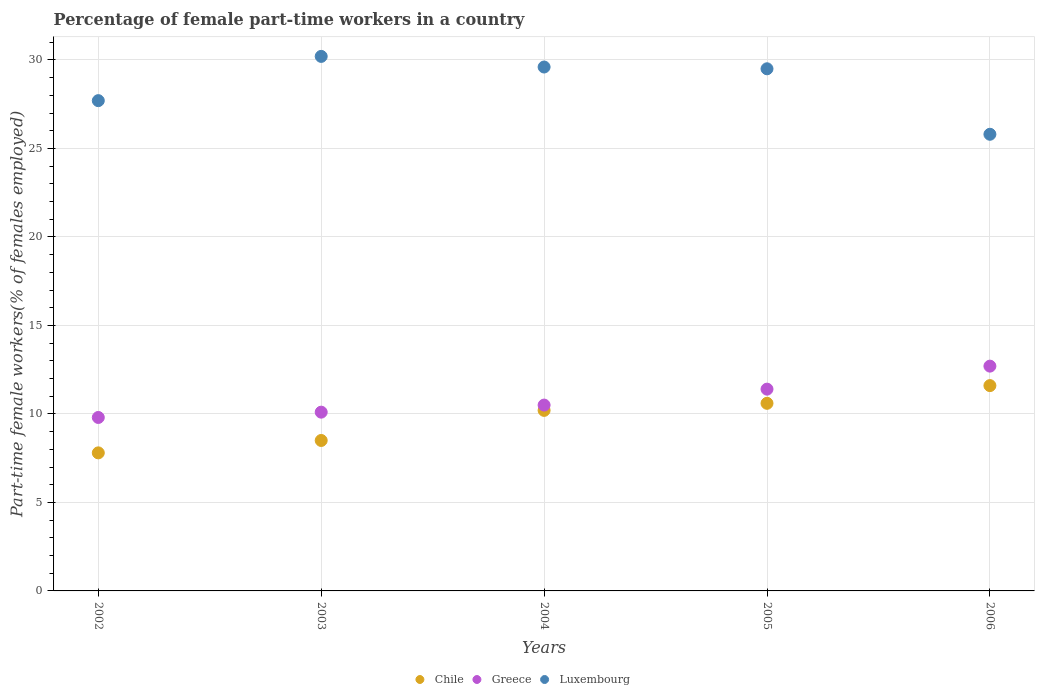What is the percentage of female part-time workers in Chile in 2004?
Keep it short and to the point. 10.2. Across all years, what is the maximum percentage of female part-time workers in Greece?
Provide a short and direct response. 12.7. Across all years, what is the minimum percentage of female part-time workers in Greece?
Provide a short and direct response. 9.8. In which year was the percentage of female part-time workers in Luxembourg minimum?
Give a very brief answer. 2006. What is the total percentage of female part-time workers in Chile in the graph?
Give a very brief answer. 48.7. What is the difference between the percentage of female part-time workers in Chile in 2003 and that in 2006?
Your answer should be compact. -3.1. What is the difference between the percentage of female part-time workers in Luxembourg in 2006 and the percentage of female part-time workers in Chile in 2003?
Offer a terse response. 17.3. What is the average percentage of female part-time workers in Luxembourg per year?
Your answer should be very brief. 28.56. In the year 2003, what is the difference between the percentage of female part-time workers in Greece and percentage of female part-time workers in Luxembourg?
Give a very brief answer. -20.1. In how many years, is the percentage of female part-time workers in Chile greater than 12 %?
Offer a terse response. 0. What is the ratio of the percentage of female part-time workers in Chile in 2002 to that in 2003?
Provide a succinct answer. 0.92. What is the difference between the highest and the second highest percentage of female part-time workers in Chile?
Make the answer very short. 1. What is the difference between the highest and the lowest percentage of female part-time workers in Greece?
Offer a terse response. 2.9. Is the percentage of female part-time workers in Chile strictly less than the percentage of female part-time workers in Greece over the years?
Provide a short and direct response. Yes. How many dotlines are there?
Make the answer very short. 3. How many years are there in the graph?
Provide a short and direct response. 5. Does the graph contain any zero values?
Your answer should be very brief. No. Where does the legend appear in the graph?
Provide a short and direct response. Bottom center. How many legend labels are there?
Give a very brief answer. 3. What is the title of the graph?
Give a very brief answer. Percentage of female part-time workers in a country. Does "Pacific island small states" appear as one of the legend labels in the graph?
Ensure brevity in your answer.  No. What is the label or title of the Y-axis?
Offer a terse response. Part-time female workers(% of females employed). What is the Part-time female workers(% of females employed) of Chile in 2002?
Ensure brevity in your answer.  7.8. What is the Part-time female workers(% of females employed) in Greece in 2002?
Your response must be concise. 9.8. What is the Part-time female workers(% of females employed) in Luxembourg in 2002?
Give a very brief answer. 27.7. What is the Part-time female workers(% of females employed) of Chile in 2003?
Offer a very short reply. 8.5. What is the Part-time female workers(% of females employed) in Greece in 2003?
Offer a very short reply. 10.1. What is the Part-time female workers(% of females employed) of Luxembourg in 2003?
Provide a short and direct response. 30.2. What is the Part-time female workers(% of females employed) of Chile in 2004?
Your response must be concise. 10.2. What is the Part-time female workers(% of females employed) of Luxembourg in 2004?
Your response must be concise. 29.6. What is the Part-time female workers(% of females employed) in Chile in 2005?
Provide a succinct answer. 10.6. What is the Part-time female workers(% of females employed) of Greece in 2005?
Offer a terse response. 11.4. What is the Part-time female workers(% of females employed) of Luxembourg in 2005?
Provide a succinct answer. 29.5. What is the Part-time female workers(% of females employed) in Chile in 2006?
Offer a very short reply. 11.6. What is the Part-time female workers(% of females employed) of Greece in 2006?
Your response must be concise. 12.7. What is the Part-time female workers(% of females employed) in Luxembourg in 2006?
Provide a succinct answer. 25.8. Across all years, what is the maximum Part-time female workers(% of females employed) in Chile?
Make the answer very short. 11.6. Across all years, what is the maximum Part-time female workers(% of females employed) in Greece?
Provide a short and direct response. 12.7. Across all years, what is the maximum Part-time female workers(% of females employed) of Luxembourg?
Provide a succinct answer. 30.2. Across all years, what is the minimum Part-time female workers(% of females employed) in Chile?
Ensure brevity in your answer.  7.8. Across all years, what is the minimum Part-time female workers(% of females employed) of Greece?
Provide a succinct answer. 9.8. Across all years, what is the minimum Part-time female workers(% of females employed) of Luxembourg?
Offer a very short reply. 25.8. What is the total Part-time female workers(% of females employed) in Chile in the graph?
Offer a very short reply. 48.7. What is the total Part-time female workers(% of females employed) of Greece in the graph?
Offer a terse response. 54.5. What is the total Part-time female workers(% of females employed) in Luxembourg in the graph?
Ensure brevity in your answer.  142.8. What is the difference between the Part-time female workers(% of females employed) of Chile in 2002 and that in 2003?
Offer a very short reply. -0.7. What is the difference between the Part-time female workers(% of females employed) in Chile in 2002 and that in 2004?
Give a very brief answer. -2.4. What is the difference between the Part-time female workers(% of females employed) in Greece in 2002 and that in 2004?
Provide a succinct answer. -0.7. What is the difference between the Part-time female workers(% of females employed) of Luxembourg in 2002 and that in 2004?
Your response must be concise. -1.9. What is the difference between the Part-time female workers(% of females employed) of Greece in 2002 and that in 2005?
Provide a short and direct response. -1.6. What is the difference between the Part-time female workers(% of females employed) in Greece in 2002 and that in 2006?
Your answer should be very brief. -2.9. What is the difference between the Part-time female workers(% of females employed) in Luxembourg in 2002 and that in 2006?
Keep it short and to the point. 1.9. What is the difference between the Part-time female workers(% of females employed) in Greece in 2003 and that in 2004?
Your response must be concise. -0.4. What is the difference between the Part-time female workers(% of females employed) in Chile in 2003 and that in 2005?
Make the answer very short. -2.1. What is the difference between the Part-time female workers(% of females employed) in Greece in 2003 and that in 2005?
Your response must be concise. -1.3. What is the difference between the Part-time female workers(% of females employed) in Chile in 2003 and that in 2006?
Make the answer very short. -3.1. What is the difference between the Part-time female workers(% of females employed) of Greece in 2003 and that in 2006?
Your response must be concise. -2.6. What is the difference between the Part-time female workers(% of females employed) of Greece in 2005 and that in 2006?
Provide a short and direct response. -1.3. What is the difference between the Part-time female workers(% of females employed) of Chile in 2002 and the Part-time female workers(% of females employed) of Luxembourg in 2003?
Ensure brevity in your answer.  -22.4. What is the difference between the Part-time female workers(% of females employed) in Greece in 2002 and the Part-time female workers(% of females employed) in Luxembourg in 2003?
Provide a short and direct response. -20.4. What is the difference between the Part-time female workers(% of females employed) in Chile in 2002 and the Part-time female workers(% of females employed) in Luxembourg in 2004?
Provide a short and direct response. -21.8. What is the difference between the Part-time female workers(% of females employed) of Greece in 2002 and the Part-time female workers(% of females employed) of Luxembourg in 2004?
Your answer should be compact. -19.8. What is the difference between the Part-time female workers(% of females employed) of Chile in 2002 and the Part-time female workers(% of females employed) of Greece in 2005?
Give a very brief answer. -3.6. What is the difference between the Part-time female workers(% of females employed) of Chile in 2002 and the Part-time female workers(% of females employed) of Luxembourg in 2005?
Give a very brief answer. -21.7. What is the difference between the Part-time female workers(% of females employed) of Greece in 2002 and the Part-time female workers(% of females employed) of Luxembourg in 2005?
Ensure brevity in your answer.  -19.7. What is the difference between the Part-time female workers(% of females employed) of Chile in 2003 and the Part-time female workers(% of females employed) of Luxembourg in 2004?
Your answer should be compact. -21.1. What is the difference between the Part-time female workers(% of females employed) of Greece in 2003 and the Part-time female workers(% of females employed) of Luxembourg in 2004?
Your response must be concise. -19.5. What is the difference between the Part-time female workers(% of females employed) in Chile in 2003 and the Part-time female workers(% of females employed) in Luxembourg in 2005?
Make the answer very short. -21. What is the difference between the Part-time female workers(% of females employed) in Greece in 2003 and the Part-time female workers(% of females employed) in Luxembourg in 2005?
Your response must be concise. -19.4. What is the difference between the Part-time female workers(% of females employed) of Chile in 2003 and the Part-time female workers(% of females employed) of Luxembourg in 2006?
Ensure brevity in your answer.  -17.3. What is the difference between the Part-time female workers(% of females employed) of Greece in 2003 and the Part-time female workers(% of females employed) of Luxembourg in 2006?
Provide a short and direct response. -15.7. What is the difference between the Part-time female workers(% of females employed) of Chile in 2004 and the Part-time female workers(% of females employed) of Greece in 2005?
Provide a succinct answer. -1.2. What is the difference between the Part-time female workers(% of females employed) in Chile in 2004 and the Part-time female workers(% of females employed) in Luxembourg in 2005?
Your answer should be compact. -19.3. What is the difference between the Part-time female workers(% of females employed) of Chile in 2004 and the Part-time female workers(% of females employed) of Greece in 2006?
Give a very brief answer. -2.5. What is the difference between the Part-time female workers(% of females employed) in Chile in 2004 and the Part-time female workers(% of females employed) in Luxembourg in 2006?
Provide a short and direct response. -15.6. What is the difference between the Part-time female workers(% of females employed) in Greece in 2004 and the Part-time female workers(% of females employed) in Luxembourg in 2006?
Your answer should be very brief. -15.3. What is the difference between the Part-time female workers(% of females employed) of Chile in 2005 and the Part-time female workers(% of females employed) of Greece in 2006?
Make the answer very short. -2.1. What is the difference between the Part-time female workers(% of females employed) in Chile in 2005 and the Part-time female workers(% of females employed) in Luxembourg in 2006?
Make the answer very short. -15.2. What is the difference between the Part-time female workers(% of females employed) of Greece in 2005 and the Part-time female workers(% of females employed) of Luxembourg in 2006?
Provide a succinct answer. -14.4. What is the average Part-time female workers(% of females employed) in Chile per year?
Offer a very short reply. 9.74. What is the average Part-time female workers(% of females employed) of Luxembourg per year?
Ensure brevity in your answer.  28.56. In the year 2002, what is the difference between the Part-time female workers(% of females employed) in Chile and Part-time female workers(% of females employed) in Greece?
Ensure brevity in your answer.  -2. In the year 2002, what is the difference between the Part-time female workers(% of females employed) in Chile and Part-time female workers(% of females employed) in Luxembourg?
Your answer should be very brief. -19.9. In the year 2002, what is the difference between the Part-time female workers(% of females employed) of Greece and Part-time female workers(% of females employed) of Luxembourg?
Provide a succinct answer. -17.9. In the year 2003, what is the difference between the Part-time female workers(% of females employed) in Chile and Part-time female workers(% of females employed) in Greece?
Offer a terse response. -1.6. In the year 2003, what is the difference between the Part-time female workers(% of females employed) in Chile and Part-time female workers(% of females employed) in Luxembourg?
Ensure brevity in your answer.  -21.7. In the year 2003, what is the difference between the Part-time female workers(% of females employed) of Greece and Part-time female workers(% of females employed) of Luxembourg?
Your response must be concise. -20.1. In the year 2004, what is the difference between the Part-time female workers(% of females employed) in Chile and Part-time female workers(% of females employed) in Greece?
Offer a terse response. -0.3. In the year 2004, what is the difference between the Part-time female workers(% of females employed) in Chile and Part-time female workers(% of females employed) in Luxembourg?
Offer a very short reply. -19.4. In the year 2004, what is the difference between the Part-time female workers(% of females employed) in Greece and Part-time female workers(% of females employed) in Luxembourg?
Ensure brevity in your answer.  -19.1. In the year 2005, what is the difference between the Part-time female workers(% of females employed) in Chile and Part-time female workers(% of females employed) in Luxembourg?
Keep it short and to the point. -18.9. In the year 2005, what is the difference between the Part-time female workers(% of females employed) of Greece and Part-time female workers(% of females employed) of Luxembourg?
Offer a very short reply. -18.1. In the year 2006, what is the difference between the Part-time female workers(% of females employed) of Greece and Part-time female workers(% of females employed) of Luxembourg?
Give a very brief answer. -13.1. What is the ratio of the Part-time female workers(% of females employed) of Chile in 2002 to that in 2003?
Your answer should be very brief. 0.92. What is the ratio of the Part-time female workers(% of females employed) in Greece in 2002 to that in 2003?
Offer a terse response. 0.97. What is the ratio of the Part-time female workers(% of females employed) in Luxembourg in 2002 to that in 2003?
Provide a succinct answer. 0.92. What is the ratio of the Part-time female workers(% of females employed) in Chile in 2002 to that in 2004?
Provide a short and direct response. 0.76. What is the ratio of the Part-time female workers(% of females employed) in Greece in 2002 to that in 2004?
Your answer should be compact. 0.93. What is the ratio of the Part-time female workers(% of females employed) of Luxembourg in 2002 to that in 2004?
Provide a succinct answer. 0.94. What is the ratio of the Part-time female workers(% of females employed) in Chile in 2002 to that in 2005?
Your answer should be compact. 0.74. What is the ratio of the Part-time female workers(% of females employed) in Greece in 2002 to that in 2005?
Offer a very short reply. 0.86. What is the ratio of the Part-time female workers(% of females employed) of Luxembourg in 2002 to that in 2005?
Provide a succinct answer. 0.94. What is the ratio of the Part-time female workers(% of females employed) of Chile in 2002 to that in 2006?
Offer a very short reply. 0.67. What is the ratio of the Part-time female workers(% of females employed) in Greece in 2002 to that in 2006?
Your answer should be compact. 0.77. What is the ratio of the Part-time female workers(% of females employed) of Luxembourg in 2002 to that in 2006?
Provide a succinct answer. 1.07. What is the ratio of the Part-time female workers(% of females employed) of Chile in 2003 to that in 2004?
Offer a terse response. 0.83. What is the ratio of the Part-time female workers(% of females employed) of Greece in 2003 to that in 2004?
Ensure brevity in your answer.  0.96. What is the ratio of the Part-time female workers(% of females employed) in Luxembourg in 2003 to that in 2004?
Your answer should be compact. 1.02. What is the ratio of the Part-time female workers(% of females employed) of Chile in 2003 to that in 2005?
Provide a succinct answer. 0.8. What is the ratio of the Part-time female workers(% of females employed) in Greece in 2003 to that in 2005?
Your answer should be very brief. 0.89. What is the ratio of the Part-time female workers(% of females employed) in Luxembourg in 2003 to that in 2005?
Keep it short and to the point. 1.02. What is the ratio of the Part-time female workers(% of females employed) of Chile in 2003 to that in 2006?
Keep it short and to the point. 0.73. What is the ratio of the Part-time female workers(% of females employed) of Greece in 2003 to that in 2006?
Your response must be concise. 0.8. What is the ratio of the Part-time female workers(% of females employed) in Luxembourg in 2003 to that in 2006?
Your answer should be compact. 1.17. What is the ratio of the Part-time female workers(% of females employed) in Chile in 2004 to that in 2005?
Provide a short and direct response. 0.96. What is the ratio of the Part-time female workers(% of females employed) of Greece in 2004 to that in 2005?
Make the answer very short. 0.92. What is the ratio of the Part-time female workers(% of females employed) of Luxembourg in 2004 to that in 2005?
Your response must be concise. 1. What is the ratio of the Part-time female workers(% of females employed) in Chile in 2004 to that in 2006?
Give a very brief answer. 0.88. What is the ratio of the Part-time female workers(% of females employed) in Greece in 2004 to that in 2006?
Offer a terse response. 0.83. What is the ratio of the Part-time female workers(% of females employed) of Luxembourg in 2004 to that in 2006?
Provide a short and direct response. 1.15. What is the ratio of the Part-time female workers(% of females employed) of Chile in 2005 to that in 2006?
Keep it short and to the point. 0.91. What is the ratio of the Part-time female workers(% of females employed) in Greece in 2005 to that in 2006?
Your answer should be very brief. 0.9. What is the ratio of the Part-time female workers(% of females employed) of Luxembourg in 2005 to that in 2006?
Give a very brief answer. 1.14. What is the difference between the highest and the lowest Part-time female workers(% of females employed) in Chile?
Your answer should be very brief. 3.8. What is the difference between the highest and the lowest Part-time female workers(% of females employed) of Luxembourg?
Provide a succinct answer. 4.4. 